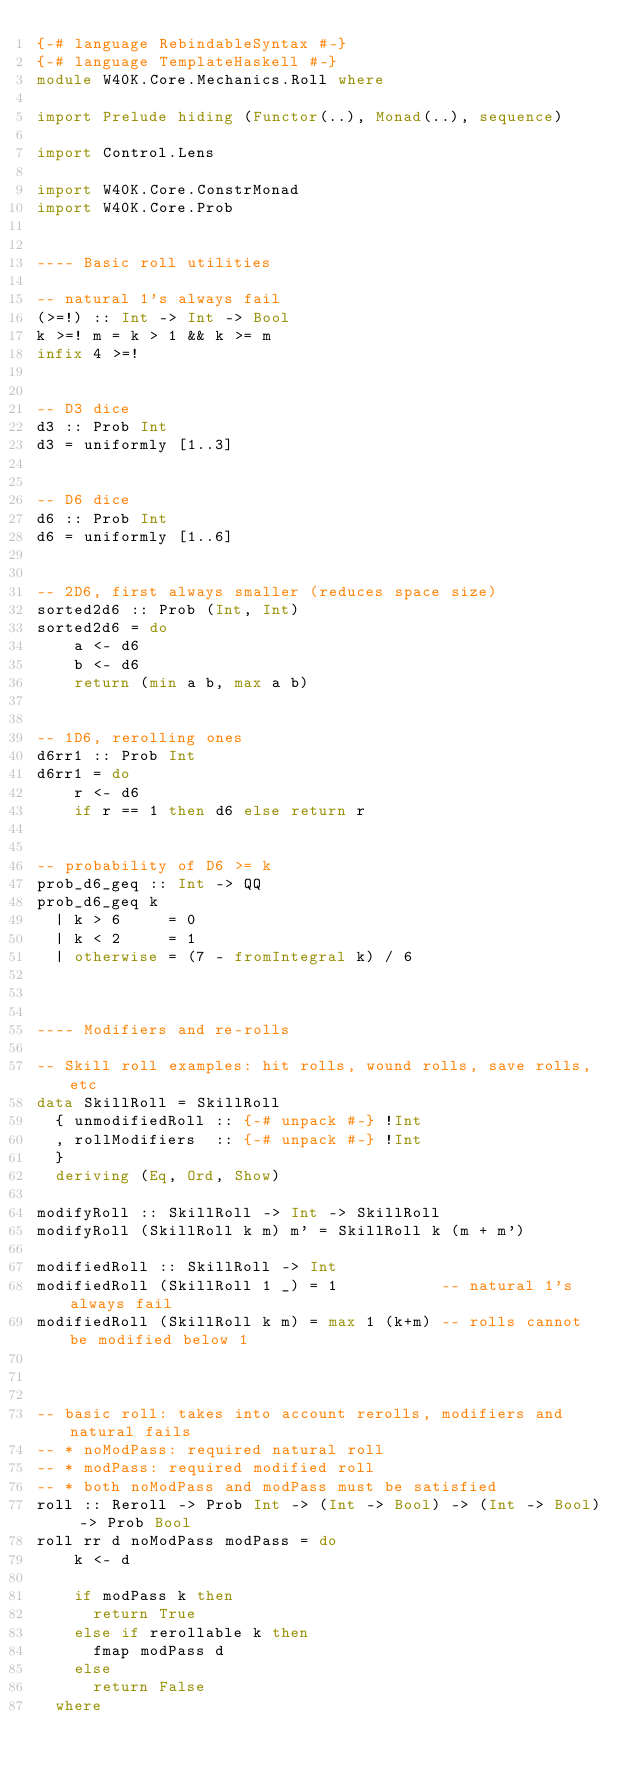Convert code to text. <code><loc_0><loc_0><loc_500><loc_500><_Haskell_>{-# language RebindableSyntax #-}
{-# language TemplateHaskell #-}
module W40K.Core.Mechanics.Roll where

import Prelude hiding (Functor(..), Monad(..), sequence)

import Control.Lens

import W40K.Core.ConstrMonad
import W40K.Core.Prob


---- Basic roll utilities

-- natural 1's always fail
(>=!) :: Int -> Int -> Bool
k >=! m = k > 1 && k >= m
infix 4 >=!


-- D3 dice
d3 :: Prob Int
d3 = uniformly [1..3]


-- D6 dice
d6 :: Prob Int
d6 = uniformly [1..6]


-- 2D6, first always smaller (reduces space size)
sorted2d6 :: Prob (Int, Int)
sorted2d6 = do
    a <- d6
    b <- d6
    return (min a b, max a b)


-- 1D6, rerolling ones
d6rr1 :: Prob Int
d6rr1 = do
    r <- d6
    if r == 1 then d6 else return r


-- probability of D6 >= k
prob_d6_geq :: Int -> QQ
prob_d6_geq k
  | k > 6     = 0
  | k < 2     = 1
  | otherwise = (7 - fromIntegral k) / 6



---- Modifiers and re-rolls

-- Skill roll examples: hit rolls, wound rolls, save rolls, etc
data SkillRoll = SkillRoll
  { unmodifiedRoll :: {-# unpack #-} !Int
  , rollModifiers  :: {-# unpack #-} !Int
  }
  deriving (Eq, Ord, Show)

modifyRoll :: SkillRoll -> Int -> SkillRoll
modifyRoll (SkillRoll k m) m' = SkillRoll k (m + m')

modifiedRoll :: SkillRoll -> Int
modifiedRoll (SkillRoll 1 _) = 1           -- natural 1's always fail
modifiedRoll (SkillRoll k m) = max 1 (k+m) -- rolls cannot be modified below 1



-- basic roll: takes into account rerolls, modifiers and natural fails
-- * noModPass: required natural roll
-- * modPass: required modified roll
-- * both noModPass and modPass must be satisfied
roll :: Reroll -> Prob Int -> (Int -> Bool) -> (Int -> Bool) -> Prob Bool
roll rr d noModPass modPass = do
    k <- d

    if modPass k then
      return True
    else if rerollable k then
      fmap modPass d
    else
      return False
  where</code> 